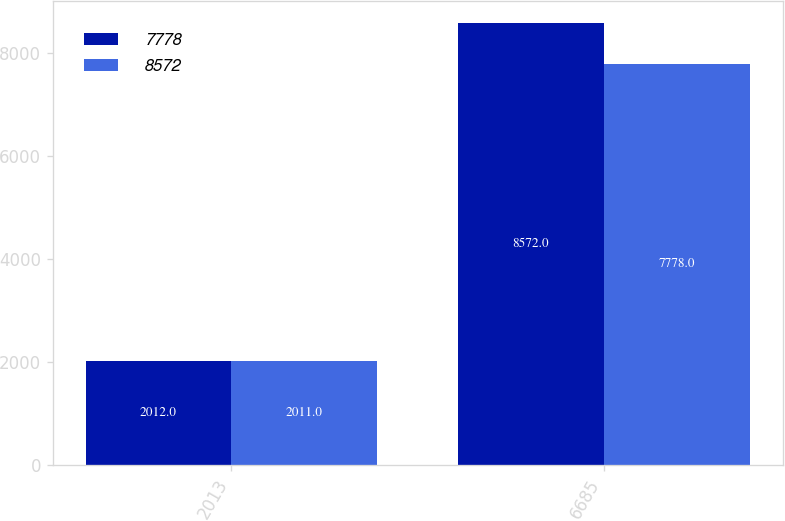Convert chart to OTSL. <chart><loc_0><loc_0><loc_500><loc_500><stacked_bar_chart><ecel><fcel>2013<fcel>6685<nl><fcel>7778<fcel>2012<fcel>8572<nl><fcel>8572<fcel>2011<fcel>7778<nl></chart> 